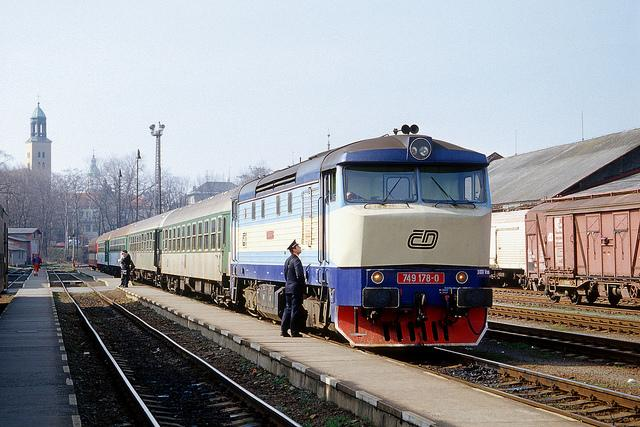What does this vehicle travel on? rails 